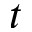<formula> <loc_0><loc_0><loc_500><loc_500>t</formula> 